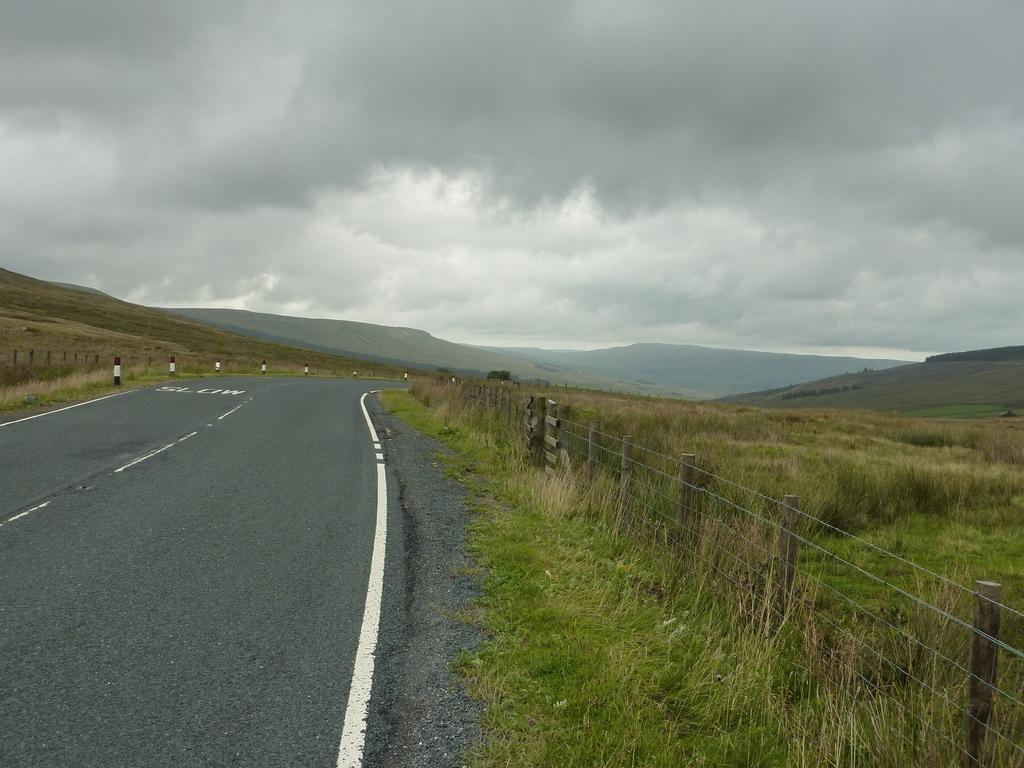What is the main feature of the image? There is a road in the image. What can be seen on both sides of the road? There are fences on both sides of the road. How are the fences attached? The fences are attached to poles. What type of vegetation is present near the road? Grass is present near the road. What geographical features can be seen in the image? There are hills visible in the image. How would you describe the weather in the image? The sky is cloudy in the image. What type of magic is being performed with the copper balloon in the image? There is no magic or balloon present in the image. 